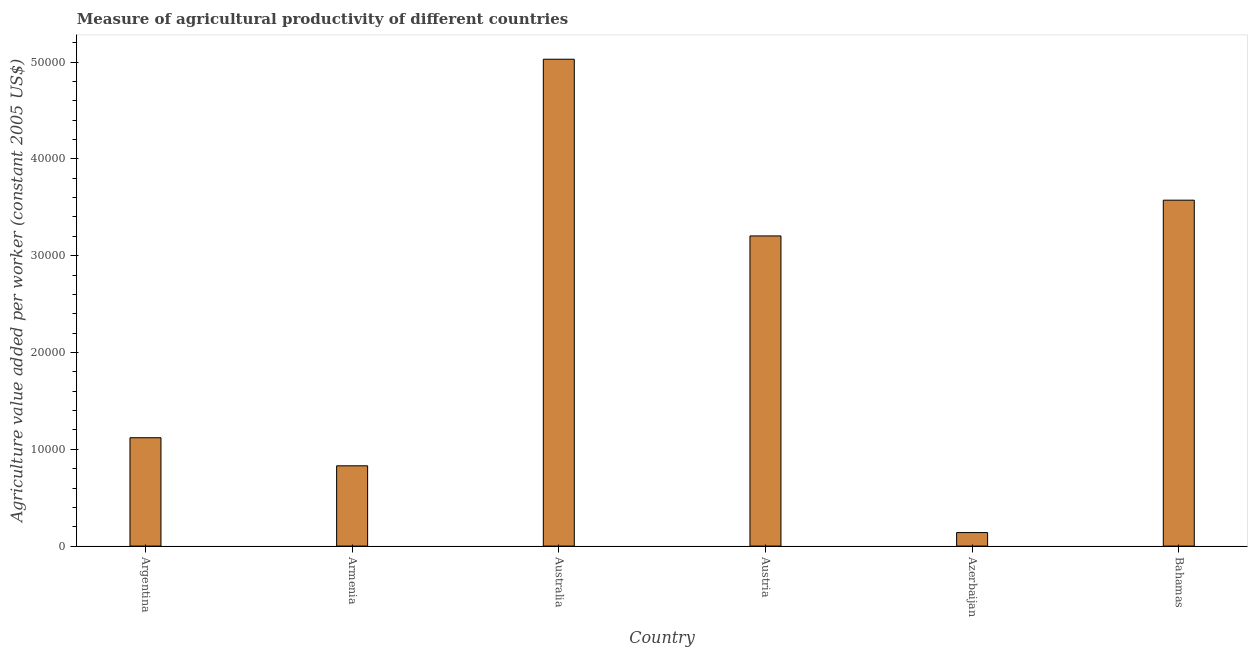Does the graph contain grids?
Your answer should be compact. No. What is the title of the graph?
Provide a short and direct response. Measure of agricultural productivity of different countries. What is the label or title of the X-axis?
Provide a short and direct response. Country. What is the label or title of the Y-axis?
Ensure brevity in your answer.  Agriculture value added per worker (constant 2005 US$). What is the agriculture value added per worker in Azerbaijan?
Give a very brief answer. 1396.89. Across all countries, what is the maximum agriculture value added per worker?
Offer a very short reply. 5.03e+04. Across all countries, what is the minimum agriculture value added per worker?
Offer a very short reply. 1396.89. In which country was the agriculture value added per worker maximum?
Ensure brevity in your answer.  Australia. In which country was the agriculture value added per worker minimum?
Offer a very short reply. Azerbaijan. What is the sum of the agriculture value added per worker?
Your answer should be compact. 1.39e+05. What is the difference between the agriculture value added per worker in Armenia and Bahamas?
Give a very brief answer. -2.74e+04. What is the average agriculture value added per worker per country?
Provide a short and direct response. 2.32e+04. What is the median agriculture value added per worker?
Give a very brief answer. 2.16e+04. In how many countries, is the agriculture value added per worker greater than 24000 US$?
Make the answer very short. 3. What is the ratio of the agriculture value added per worker in Armenia to that in Azerbaijan?
Make the answer very short. 5.94. Is the agriculture value added per worker in Armenia less than that in Austria?
Provide a short and direct response. Yes. Is the difference between the agriculture value added per worker in Armenia and Australia greater than the difference between any two countries?
Keep it short and to the point. No. What is the difference between the highest and the second highest agriculture value added per worker?
Your response must be concise. 1.46e+04. Is the sum of the agriculture value added per worker in Argentina and Austria greater than the maximum agriculture value added per worker across all countries?
Offer a terse response. No. What is the difference between the highest and the lowest agriculture value added per worker?
Offer a very short reply. 4.89e+04. How many bars are there?
Make the answer very short. 6. Are all the bars in the graph horizontal?
Offer a very short reply. No. How many countries are there in the graph?
Ensure brevity in your answer.  6. What is the Agriculture value added per worker (constant 2005 US$) in Argentina?
Keep it short and to the point. 1.12e+04. What is the Agriculture value added per worker (constant 2005 US$) in Armenia?
Your answer should be very brief. 8294.99. What is the Agriculture value added per worker (constant 2005 US$) of Australia?
Give a very brief answer. 5.03e+04. What is the Agriculture value added per worker (constant 2005 US$) in Austria?
Give a very brief answer. 3.20e+04. What is the Agriculture value added per worker (constant 2005 US$) in Azerbaijan?
Your response must be concise. 1396.89. What is the Agriculture value added per worker (constant 2005 US$) of Bahamas?
Offer a very short reply. 3.57e+04. What is the difference between the Agriculture value added per worker (constant 2005 US$) in Argentina and Armenia?
Provide a succinct answer. 2900.42. What is the difference between the Agriculture value added per worker (constant 2005 US$) in Argentina and Australia?
Make the answer very short. -3.91e+04. What is the difference between the Agriculture value added per worker (constant 2005 US$) in Argentina and Austria?
Ensure brevity in your answer.  -2.08e+04. What is the difference between the Agriculture value added per worker (constant 2005 US$) in Argentina and Azerbaijan?
Offer a very short reply. 9798.52. What is the difference between the Agriculture value added per worker (constant 2005 US$) in Argentina and Bahamas?
Your answer should be compact. -2.45e+04. What is the difference between the Agriculture value added per worker (constant 2005 US$) in Armenia and Australia?
Make the answer very short. -4.20e+04. What is the difference between the Agriculture value added per worker (constant 2005 US$) in Armenia and Austria?
Provide a succinct answer. -2.37e+04. What is the difference between the Agriculture value added per worker (constant 2005 US$) in Armenia and Azerbaijan?
Offer a very short reply. 6898.1. What is the difference between the Agriculture value added per worker (constant 2005 US$) in Armenia and Bahamas?
Provide a succinct answer. -2.74e+04. What is the difference between the Agriculture value added per worker (constant 2005 US$) in Australia and Austria?
Give a very brief answer. 1.83e+04. What is the difference between the Agriculture value added per worker (constant 2005 US$) in Australia and Azerbaijan?
Offer a very short reply. 4.89e+04. What is the difference between the Agriculture value added per worker (constant 2005 US$) in Australia and Bahamas?
Offer a terse response. 1.46e+04. What is the difference between the Agriculture value added per worker (constant 2005 US$) in Austria and Azerbaijan?
Provide a succinct answer. 3.06e+04. What is the difference between the Agriculture value added per worker (constant 2005 US$) in Austria and Bahamas?
Your response must be concise. -3694.46. What is the difference between the Agriculture value added per worker (constant 2005 US$) in Azerbaijan and Bahamas?
Make the answer very short. -3.43e+04. What is the ratio of the Agriculture value added per worker (constant 2005 US$) in Argentina to that in Armenia?
Provide a succinct answer. 1.35. What is the ratio of the Agriculture value added per worker (constant 2005 US$) in Argentina to that in Australia?
Keep it short and to the point. 0.22. What is the ratio of the Agriculture value added per worker (constant 2005 US$) in Argentina to that in Austria?
Ensure brevity in your answer.  0.35. What is the ratio of the Agriculture value added per worker (constant 2005 US$) in Argentina to that in Azerbaijan?
Ensure brevity in your answer.  8.02. What is the ratio of the Agriculture value added per worker (constant 2005 US$) in Argentina to that in Bahamas?
Make the answer very short. 0.31. What is the ratio of the Agriculture value added per worker (constant 2005 US$) in Armenia to that in Australia?
Keep it short and to the point. 0.17. What is the ratio of the Agriculture value added per worker (constant 2005 US$) in Armenia to that in Austria?
Offer a very short reply. 0.26. What is the ratio of the Agriculture value added per worker (constant 2005 US$) in Armenia to that in Azerbaijan?
Your response must be concise. 5.94. What is the ratio of the Agriculture value added per worker (constant 2005 US$) in Armenia to that in Bahamas?
Your answer should be compact. 0.23. What is the ratio of the Agriculture value added per worker (constant 2005 US$) in Australia to that in Austria?
Give a very brief answer. 1.57. What is the ratio of the Agriculture value added per worker (constant 2005 US$) in Australia to that in Azerbaijan?
Offer a very short reply. 36.01. What is the ratio of the Agriculture value added per worker (constant 2005 US$) in Australia to that in Bahamas?
Offer a very short reply. 1.41. What is the ratio of the Agriculture value added per worker (constant 2005 US$) in Austria to that in Azerbaijan?
Your answer should be compact. 22.94. What is the ratio of the Agriculture value added per worker (constant 2005 US$) in Austria to that in Bahamas?
Your answer should be very brief. 0.9. What is the ratio of the Agriculture value added per worker (constant 2005 US$) in Azerbaijan to that in Bahamas?
Your response must be concise. 0.04. 